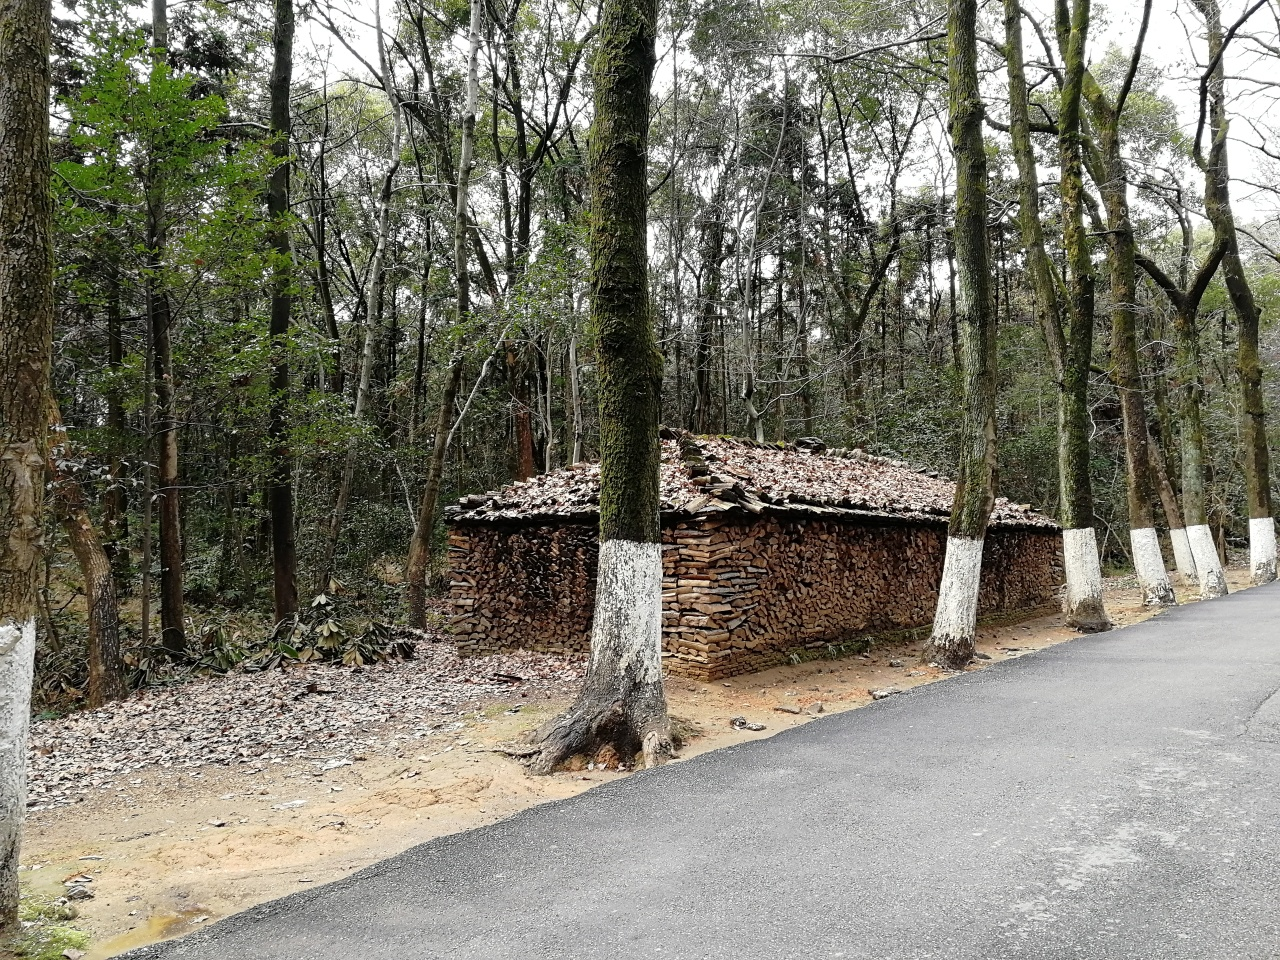How might this location be used by visitors or locals? Given the presence of a paved road, this scenic forested area could be frequented by locals for leisurely walks or drives, enjoying the natural beauty and tranquility. Visitors might use it as a picturesque route for hiking or as a rest stop to take in the serene woodland surroundings. Are there any signs of wildlife in the area? While no direct evidence of wildlife is visible in the image, the natural habitat suggests it could be home to various forest creatures. The dense underbrush and foliage might harbor small mammals, birds, and insects integral to the forest ecosystem. 